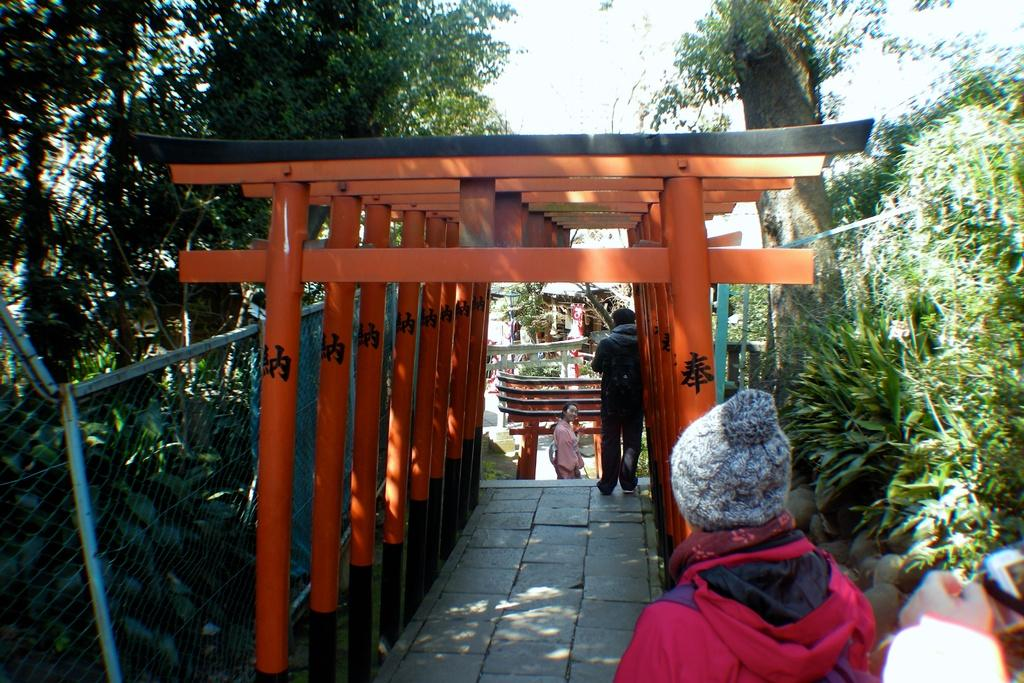What is the main subject in the center of the image? There are torii gates in the center of the image. Can you describe the people in the image? There are people in the image. What is located on the left side of the image? There is a mesh on the left side of the image. What can be seen in the background of the image? There are trees and the sky visible in the background of the image. What type of dress is the uncle wearing in the image? There is no uncle or dress present in the image. How does the brain interact with the torii gates in the image? There is no brain present in the image, and therefore no interaction with the torii gates can be observed. 